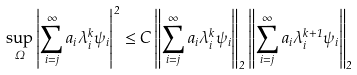<formula> <loc_0><loc_0><loc_500><loc_500>\sup _ { \Omega } \left | \sum _ { i = j } ^ { \infty } a _ { i } \lambda _ { i } ^ { k } \psi _ { i } \right | ^ { 2 } \leq C \left \| \sum _ { i = j } ^ { \infty } a _ { i } \lambda _ { i } ^ { k } \psi _ { i } \right \| _ { 2 } \left \| \sum _ { i = j } ^ { \infty } a _ { i } \lambda _ { i } ^ { k + 1 } \psi _ { i } \right \| _ { 2 }</formula> 